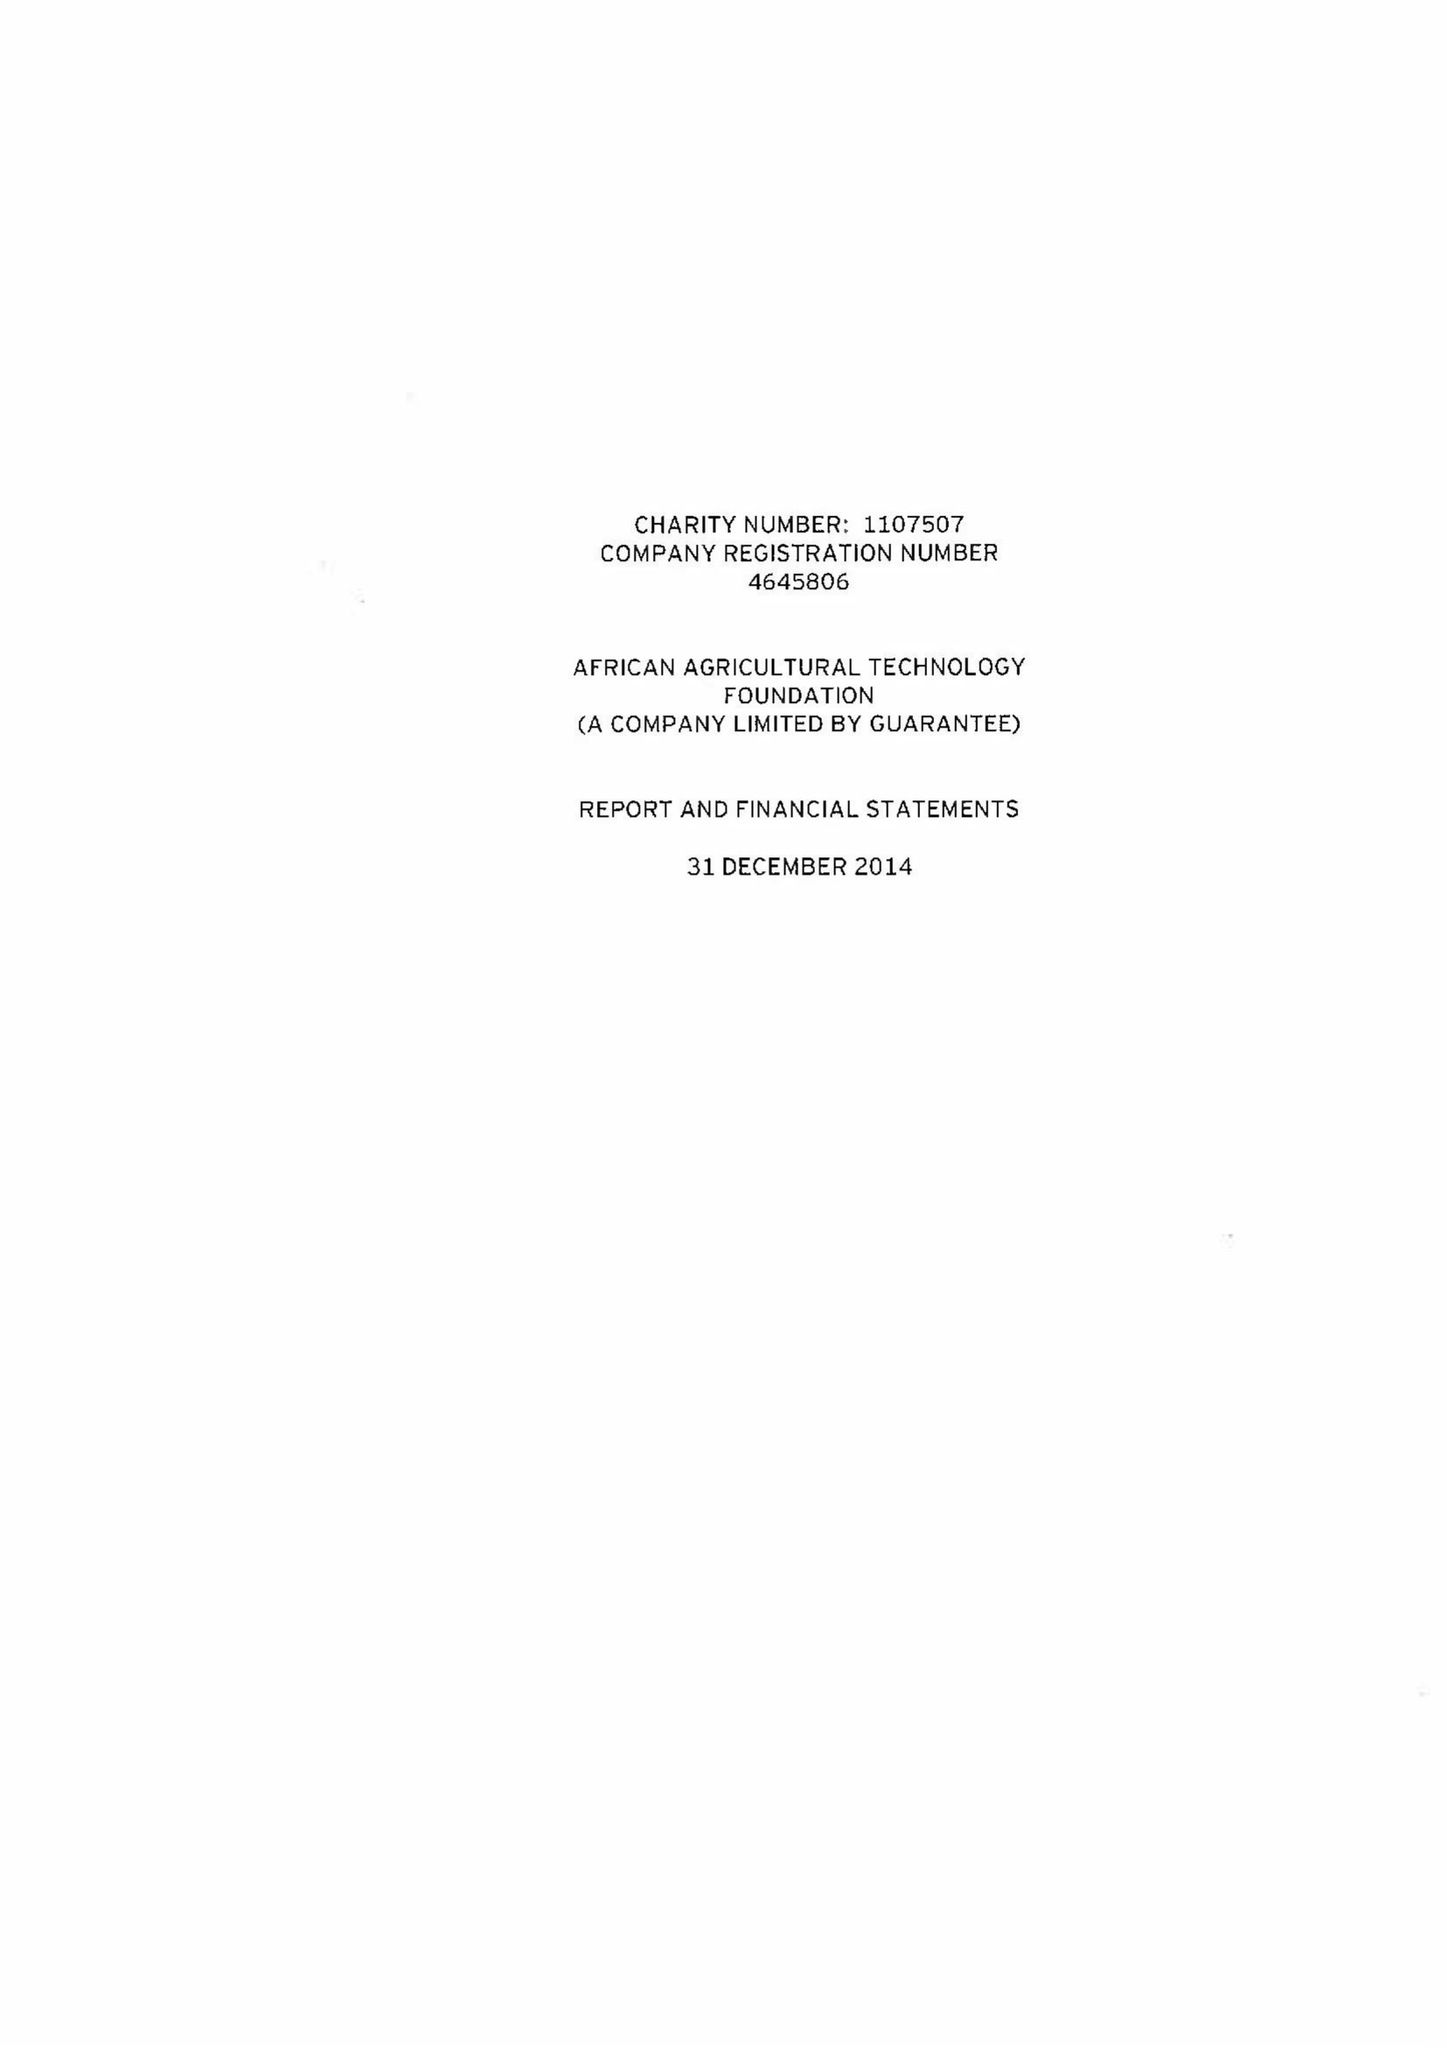What is the value for the address__postcode?
Answer the question using a single word or phrase. EC2N 1HQ 